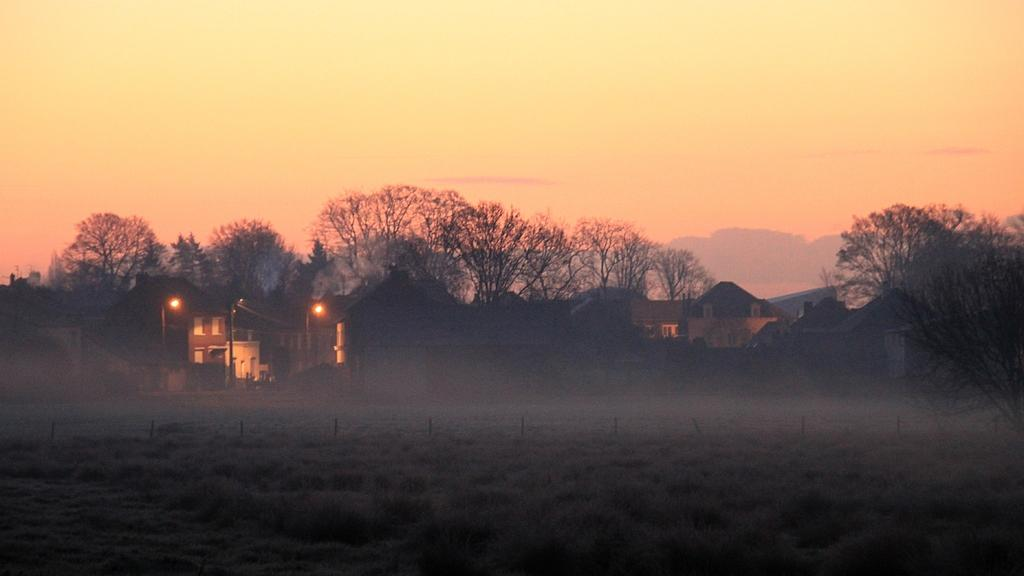What type of vegetation can be seen in the image? There are green color plants in the image. What type of structures are present in the image? There are homes in the image. What other natural elements can be seen in the image? There are trees in the image. What is visible at the top of the image? The sky is visible at the top of the image. Can you see a cracker on the table in the image? There is no table or cracker present in the image. Is there a robin perched on one of the trees in the image? There is no robin present in the image; only plants, trees, homes, and the sky are visible. 